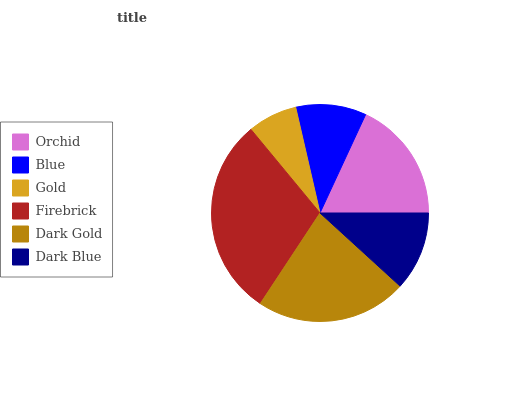Is Gold the minimum?
Answer yes or no. Yes. Is Firebrick the maximum?
Answer yes or no. Yes. Is Blue the minimum?
Answer yes or no. No. Is Blue the maximum?
Answer yes or no. No. Is Orchid greater than Blue?
Answer yes or no. Yes. Is Blue less than Orchid?
Answer yes or no. Yes. Is Blue greater than Orchid?
Answer yes or no. No. Is Orchid less than Blue?
Answer yes or no. No. Is Orchid the high median?
Answer yes or no. Yes. Is Dark Blue the low median?
Answer yes or no. Yes. Is Dark Gold the high median?
Answer yes or no. No. Is Blue the low median?
Answer yes or no. No. 